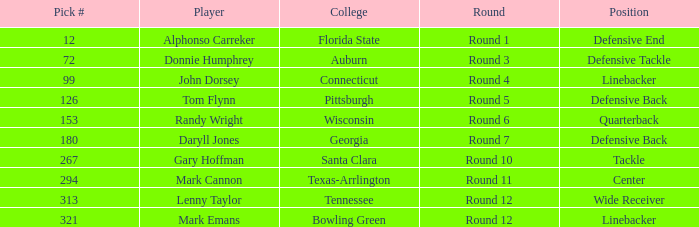In what Round was Pick #12 drafted? Round 1. Would you be able to parse every entry in this table? {'header': ['Pick #', 'Player', 'College', 'Round', 'Position'], 'rows': [['12', 'Alphonso Carreker', 'Florida State', 'Round 1', 'Defensive End'], ['72', 'Donnie Humphrey', 'Auburn', 'Round 3', 'Defensive Tackle'], ['99', 'John Dorsey', 'Connecticut', 'Round 4', 'Linebacker'], ['126', 'Tom Flynn', 'Pittsburgh', 'Round 5', 'Defensive Back'], ['153', 'Randy Wright', 'Wisconsin', 'Round 6', 'Quarterback'], ['180', 'Daryll Jones', 'Georgia', 'Round 7', 'Defensive Back'], ['267', 'Gary Hoffman', 'Santa Clara', 'Round 10', 'Tackle'], ['294', 'Mark Cannon', 'Texas-Arrlington', 'Round 11', 'Center'], ['313', 'Lenny Taylor', 'Tennessee', 'Round 12', 'Wide Receiver'], ['321', 'Mark Emans', 'Bowling Green', 'Round 12', 'Linebacker']]} 